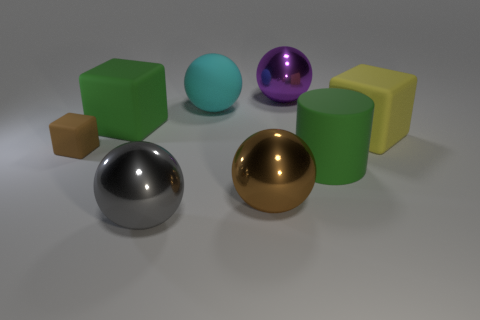There is a tiny matte object; is its color the same as the big cube right of the large purple metallic object?
Ensure brevity in your answer.  No. What is the brown thing on the right side of the brown block made of?
Your answer should be compact. Metal. What shape is the big brown object that is in front of the large green object that is in front of the brown cube?
Your answer should be very brief. Sphere. Does the tiny object have the same shape as the large green object right of the gray shiny sphere?
Make the answer very short. No. There is a metallic thing on the right side of the large brown shiny ball; what number of cyan rubber things are right of it?
Offer a terse response. 0. What is the material of the other big thing that is the same shape as the yellow object?
Provide a short and direct response. Rubber. How many blue things are either big matte balls or large rubber objects?
Your response must be concise. 0. Is there anything else that is the same color as the small matte object?
Your answer should be compact. Yes. What is the color of the big block that is on the right side of the big shiny sphere that is on the left side of the big cyan rubber object?
Your response must be concise. Yellow. Are there fewer green cylinders that are right of the yellow rubber thing than objects that are left of the purple shiny sphere?
Ensure brevity in your answer.  Yes. 